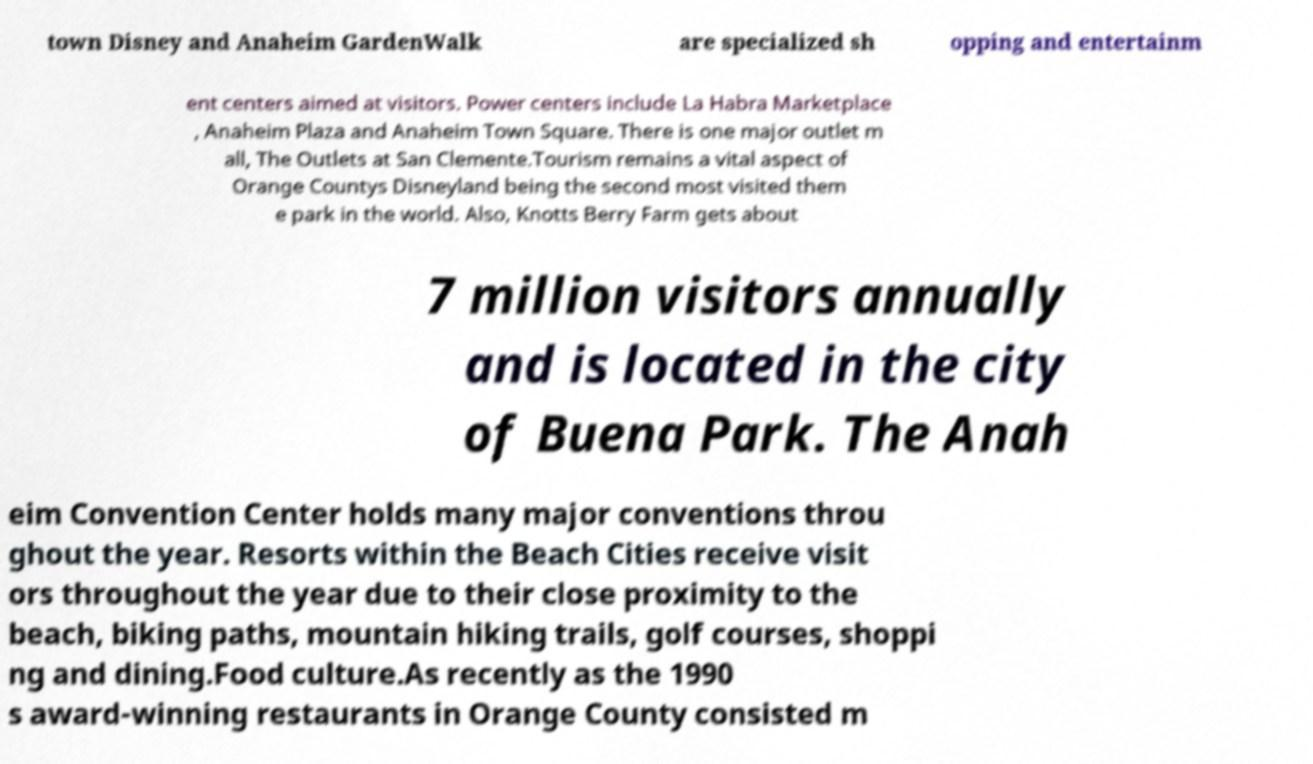Please identify and transcribe the text found in this image. town Disney and Anaheim GardenWalk are specialized sh opping and entertainm ent centers aimed at visitors. Power centers include La Habra Marketplace , Anaheim Plaza and Anaheim Town Square. There is one major outlet m all, The Outlets at San Clemente.Tourism remains a vital aspect of Orange Countys Disneyland being the second most visited them e park in the world. Also, Knotts Berry Farm gets about 7 million visitors annually and is located in the city of Buena Park. The Anah eim Convention Center holds many major conventions throu ghout the year. Resorts within the Beach Cities receive visit ors throughout the year due to their close proximity to the beach, biking paths, mountain hiking trails, golf courses, shoppi ng and dining.Food culture.As recently as the 1990 s award-winning restaurants in Orange County consisted m 